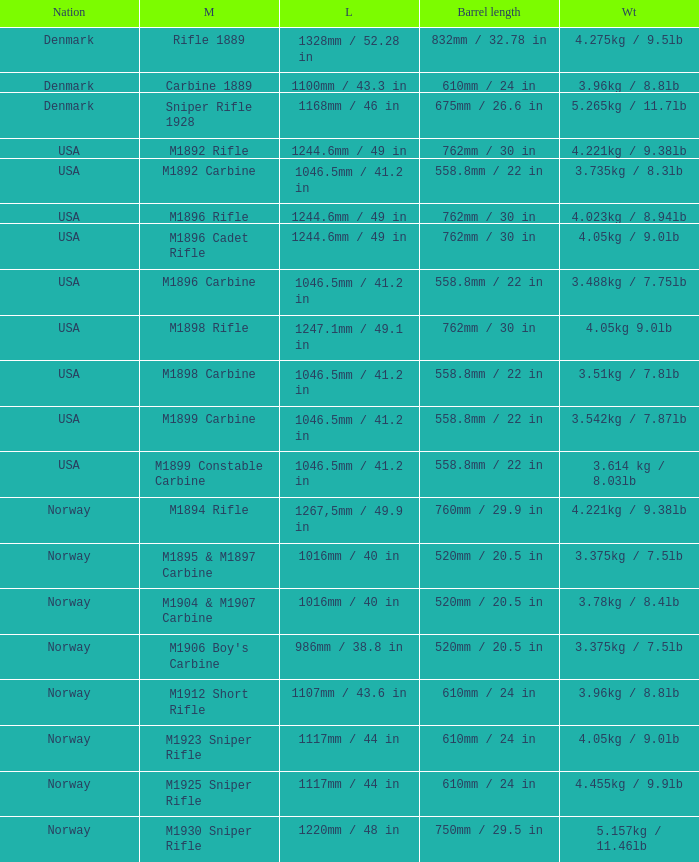What is Nation, when Model is M1895 & M1897 Carbine? Norway. 